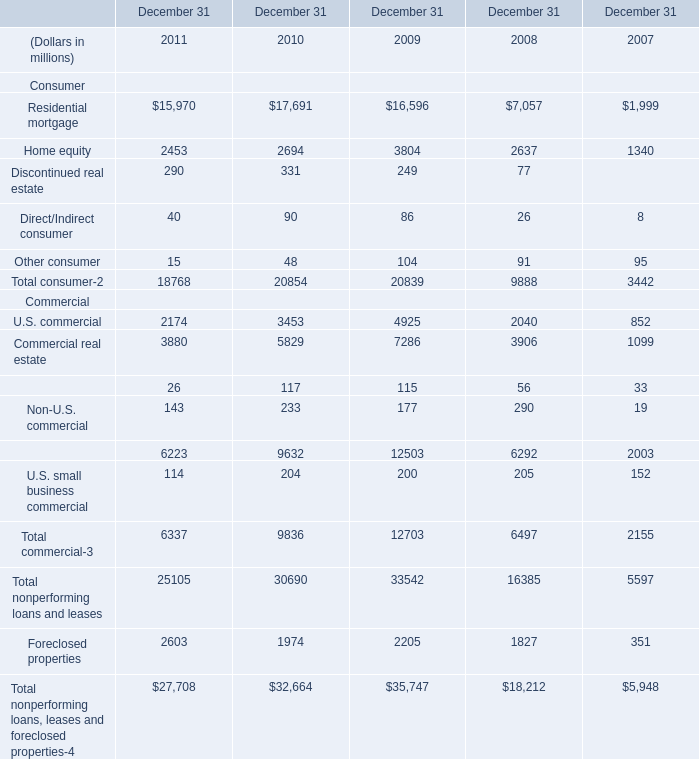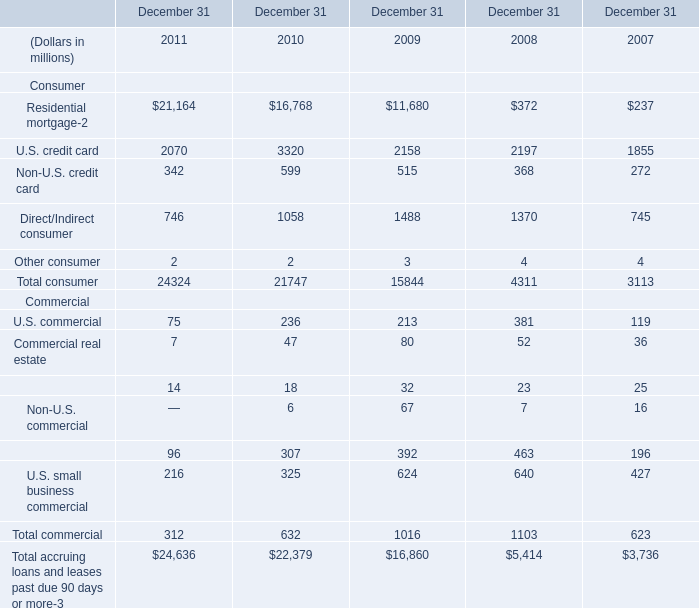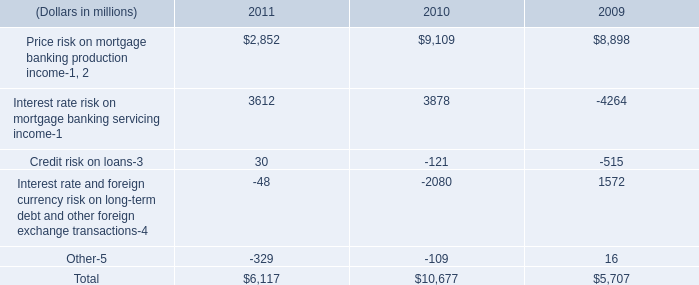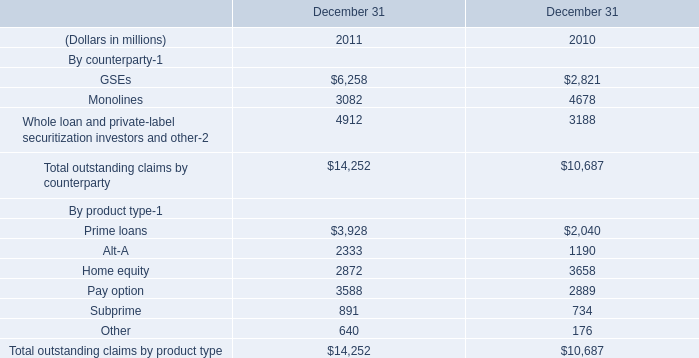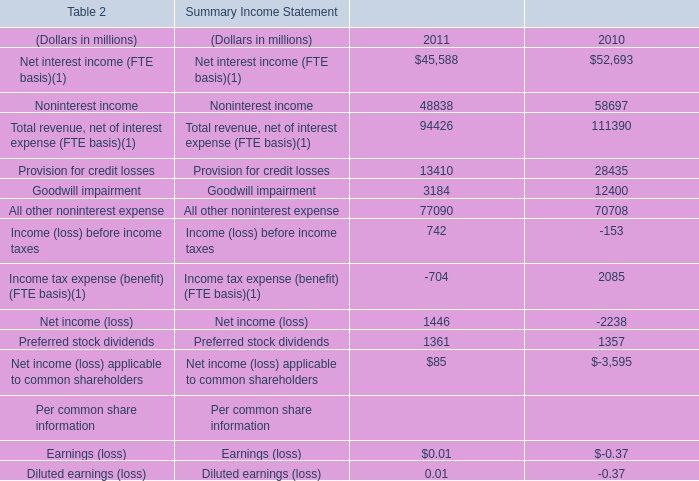What's the greatest value of Consumer in 2011? (in million) 
Answer: 21164. 